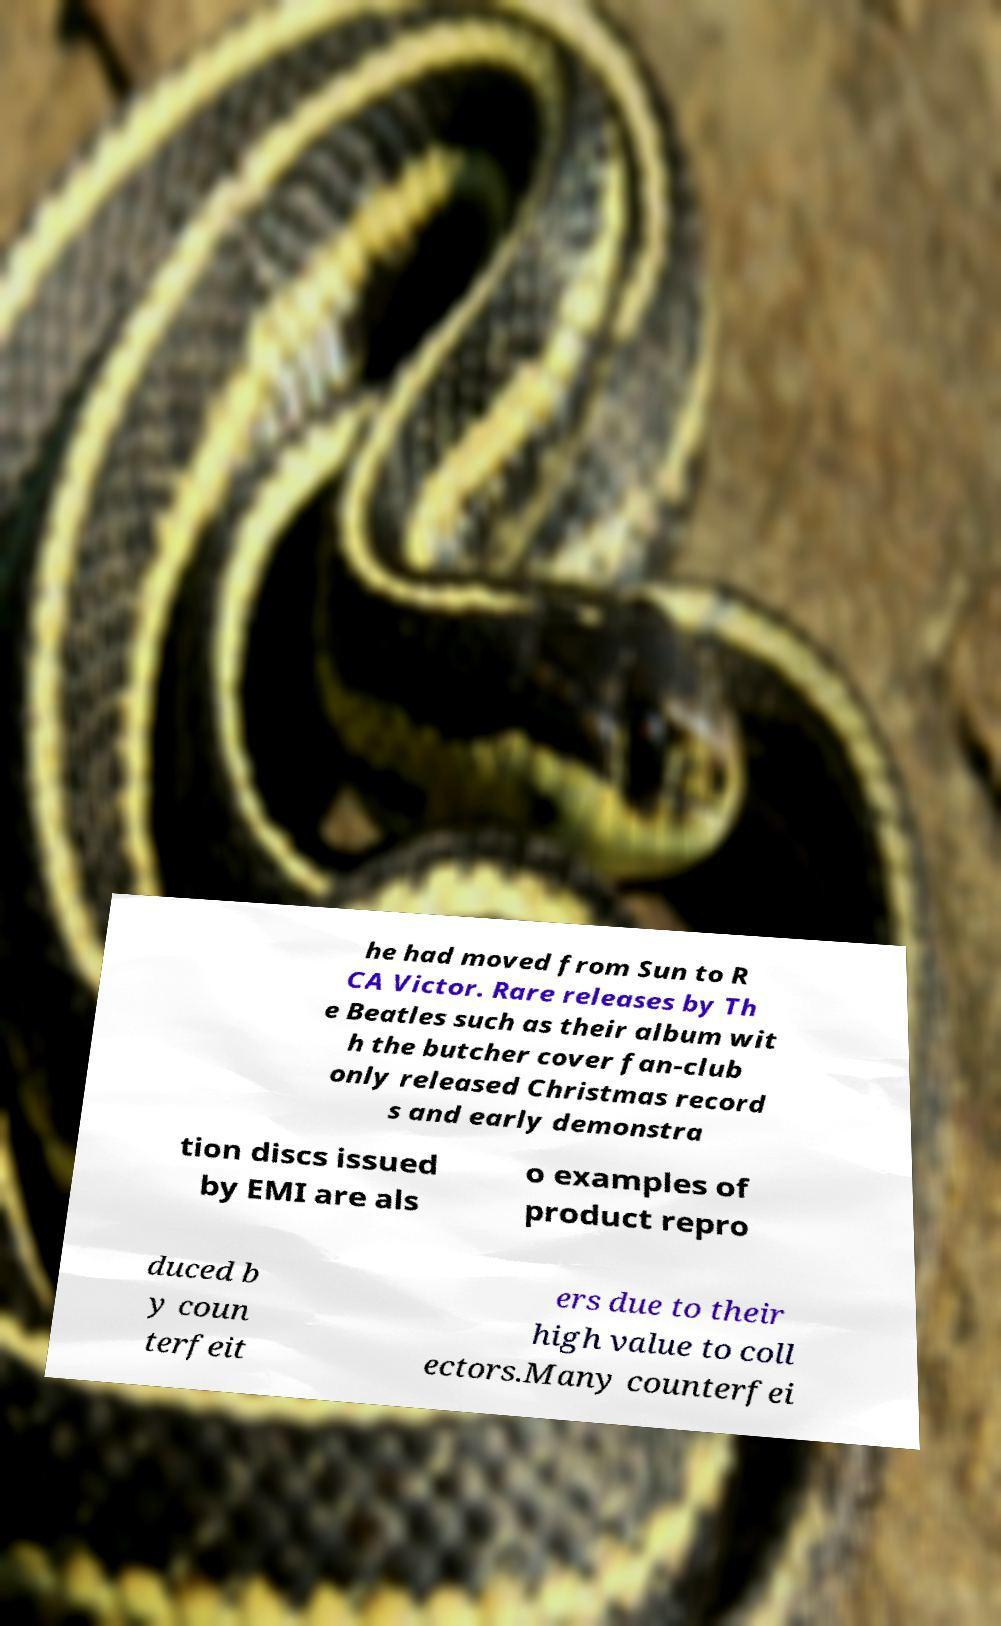What messages or text are displayed in this image? I need them in a readable, typed format. he had moved from Sun to R CA Victor. Rare releases by Th e Beatles such as their album wit h the butcher cover fan-club only released Christmas record s and early demonstra tion discs issued by EMI are als o examples of product repro duced b y coun terfeit ers due to their high value to coll ectors.Many counterfei 